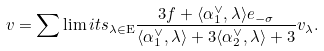Convert formula to latex. <formula><loc_0><loc_0><loc_500><loc_500>v = \sum \lim i t s _ { \lambda \in \mathrm E } \frac { 3 f + \langle \alpha _ { 1 } ^ { \vee } , \lambda \rangle e _ { - \sigma } } { \langle \alpha _ { 1 } ^ { \vee } , \lambda \rangle + 3 \langle \alpha _ { 2 } ^ { \vee } , \lambda \rangle + 3 } v _ { \lambda } .</formula> 